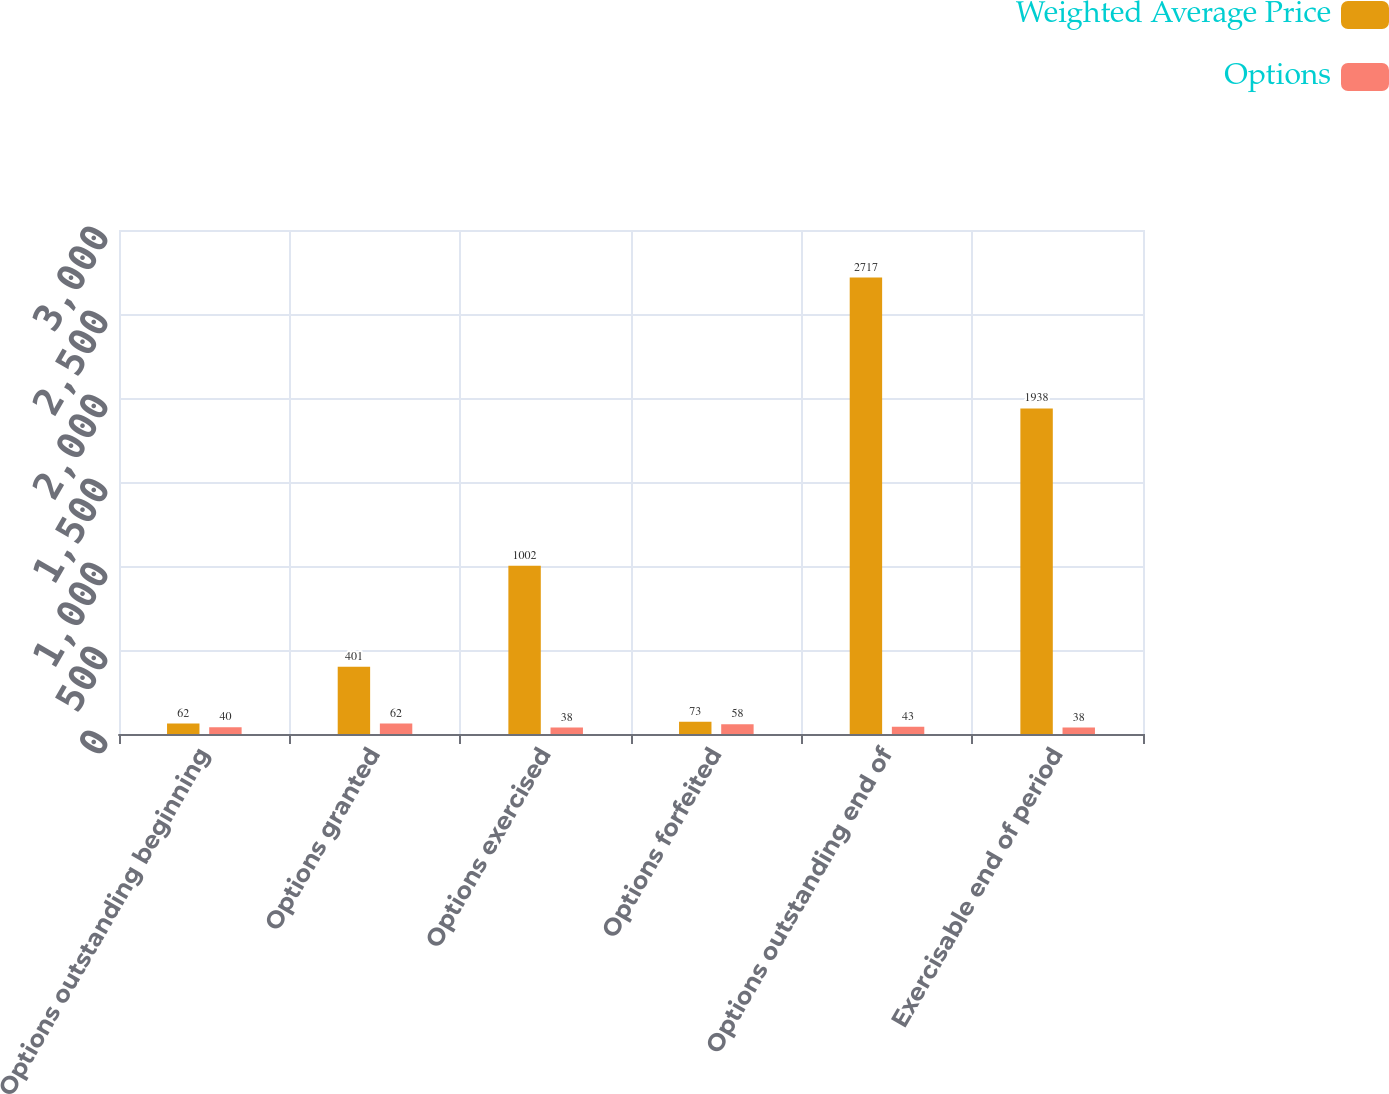Convert chart. <chart><loc_0><loc_0><loc_500><loc_500><stacked_bar_chart><ecel><fcel>Options outstanding beginning<fcel>Options granted<fcel>Options exercised<fcel>Options forfeited<fcel>Options outstanding end of<fcel>Exercisable end of period<nl><fcel>Weighted Average Price<fcel>62<fcel>401<fcel>1002<fcel>73<fcel>2717<fcel>1938<nl><fcel>Options<fcel>40<fcel>62<fcel>38<fcel>58<fcel>43<fcel>38<nl></chart> 